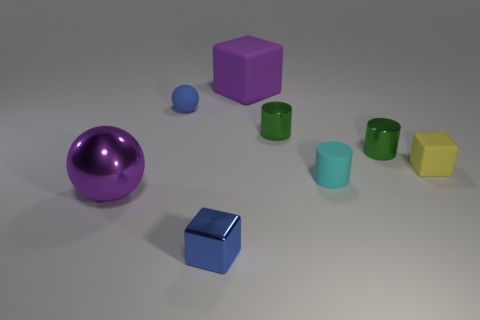Add 2 small rubber things. How many objects exist? 10 Subtract all cylinders. How many objects are left? 5 Subtract 1 blue balls. How many objects are left? 7 Subtract all cyan objects. Subtract all cyan cylinders. How many objects are left? 6 Add 3 cyan cylinders. How many cyan cylinders are left? 4 Add 3 small blue rubber objects. How many small blue rubber objects exist? 4 